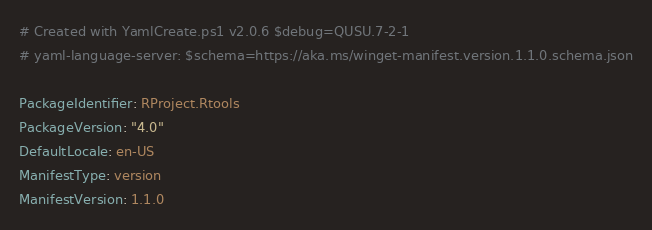Convert code to text. <code><loc_0><loc_0><loc_500><loc_500><_YAML_># Created with YamlCreate.ps1 v2.0.6 $debug=QUSU.7-2-1
# yaml-language-server: $schema=https://aka.ms/winget-manifest.version.1.1.0.schema.json

PackageIdentifier: RProject.Rtools
PackageVersion: "4.0"
DefaultLocale: en-US
ManifestType: version
ManifestVersion: 1.1.0
</code> 